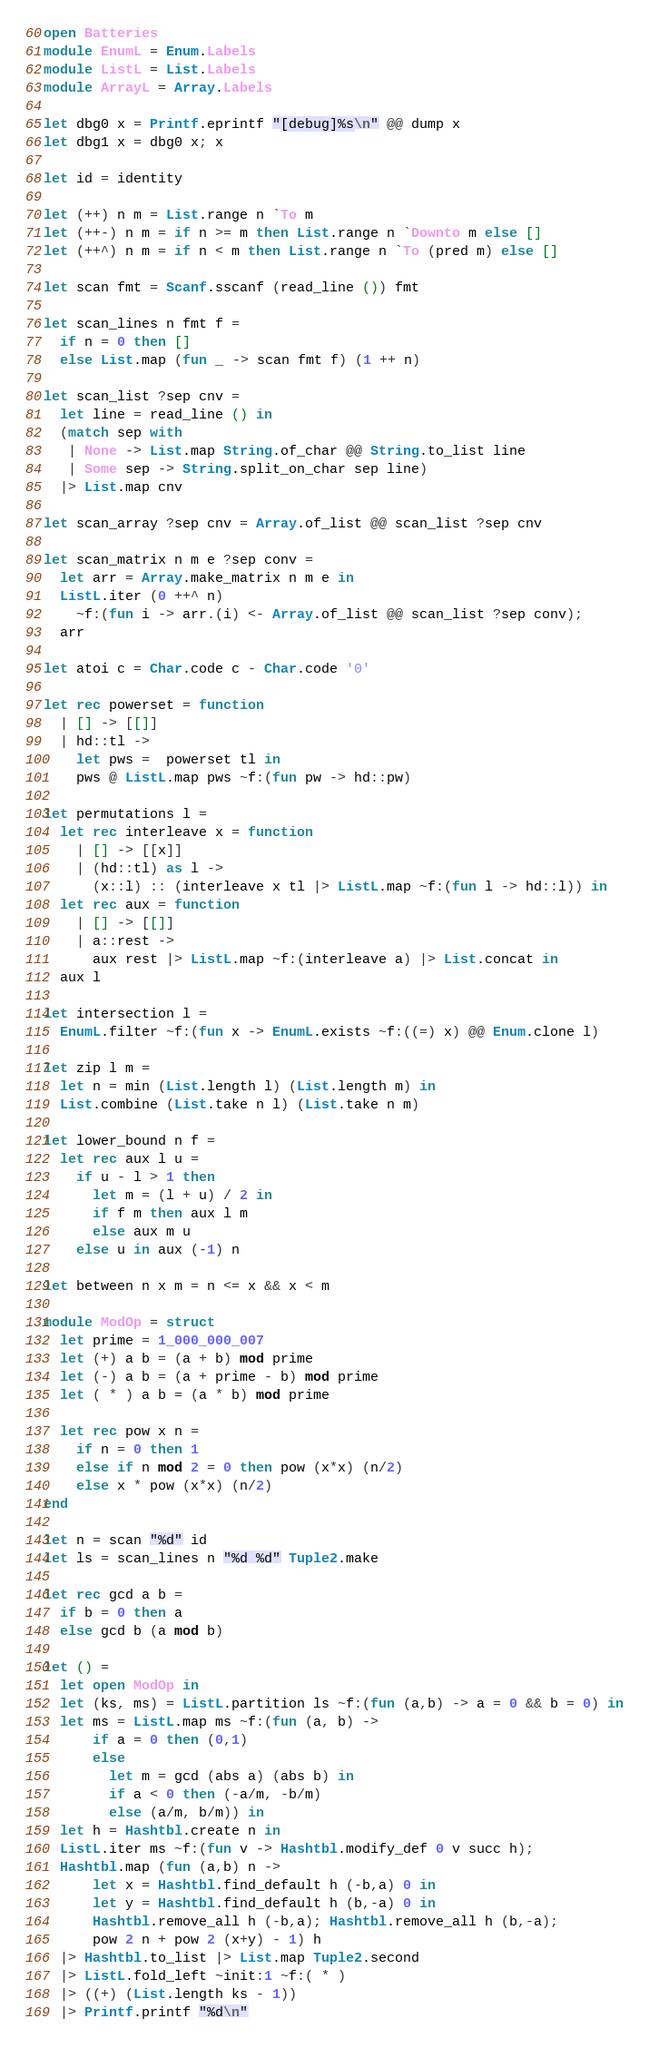<code> <loc_0><loc_0><loc_500><loc_500><_OCaml_>open Batteries
module EnumL = Enum.Labels
module ListL = List.Labels
module ArrayL = Array.Labels

let dbg0 x = Printf.eprintf "[debug]%s\n" @@ dump x
let dbg1 x = dbg0 x; x

let id = identity

let (++) n m = List.range n `To m
let (++-) n m = if n >= m then List.range n `Downto m else []
let (++^) n m = if n < m then List.range n `To (pred m) else []

let scan fmt = Scanf.sscanf (read_line ()) fmt

let scan_lines n fmt f =
  if n = 0 then []
  else List.map (fun _ -> scan fmt f) (1 ++ n)

let scan_list ?sep cnv =
  let line = read_line () in
  (match sep with
   | None -> List.map String.of_char @@ String.to_list line
   | Some sep -> String.split_on_char sep line)
  |> List.map cnv

let scan_array ?sep cnv = Array.of_list @@ scan_list ?sep cnv

let scan_matrix n m e ?sep conv =
  let arr = Array.make_matrix n m e in
  ListL.iter (0 ++^ n)
    ~f:(fun i -> arr.(i) <- Array.of_list @@ scan_list ?sep conv);
  arr

let atoi c = Char.code c - Char.code '0'

let rec powerset = function
  | [] -> [[]]
  | hd::tl ->
    let pws =  powerset tl in
    pws @ ListL.map pws ~f:(fun pw -> hd::pw)

let permutations l =
  let rec interleave x = function
    | [] -> [[x]]
    | (hd::tl) as l ->
      (x::l) :: (interleave x tl |> ListL.map ~f:(fun l -> hd::l)) in
  let rec aux = function
    | [] -> [[]]
    | a::rest ->
      aux rest |> ListL.map ~f:(interleave a) |> List.concat in
  aux l

let intersection l =
  EnumL.filter ~f:(fun x -> EnumL.exists ~f:((=) x) @@ Enum.clone l)

let zip l m =
  let n = min (List.length l) (List.length m) in
  List.combine (List.take n l) (List.take n m)

let lower_bound n f =
  let rec aux l u =
    if u - l > 1 then
      let m = (l + u) / 2 in
      if f m then aux l m
      else aux m u
    else u in aux (-1) n

let between n x m = n <= x && x < m

module ModOp = struct
  let prime = 1_000_000_007
  let (+) a b = (a + b) mod prime
  let (-) a b = (a + prime - b) mod prime
  let ( * ) a b = (a * b) mod prime

  let rec pow x n =
    if n = 0 then 1
    else if n mod 2 = 0 then pow (x*x) (n/2)
    else x * pow (x*x) (n/2)
end

let n = scan "%d" id
let ls = scan_lines n "%d %d" Tuple2.make

let rec gcd a b =
  if b = 0 then a
  else gcd b (a mod b)

let () =
  let open ModOp in
  let (ks, ms) = ListL.partition ls ~f:(fun (a,b) -> a = 0 && b = 0) in
  let ms = ListL.map ms ~f:(fun (a, b) ->
      if a = 0 then (0,1)
      else
        let m = gcd (abs a) (abs b) in
        if a < 0 then (-a/m, -b/m)
        else (a/m, b/m)) in
  let h = Hashtbl.create n in
  ListL.iter ms ~f:(fun v -> Hashtbl.modify_def 0 v succ h);
  Hashtbl.map (fun (a,b) n ->
      let x = Hashtbl.find_default h (-b,a) 0 in
      let y = Hashtbl.find_default h (b,-a) 0 in
      Hashtbl.remove_all h (-b,a); Hashtbl.remove_all h (b,-a);
      pow 2 n + pow 2 (x+y) - 1) h
  |> Hashtbl.to_list |> List.map Tuple2.second
  |> ListL.fold_left ~init:1 ~f:( * )
  |> ((+) (List.length ks - 1))
  |> Printf.printf "%d\n"
</code> 